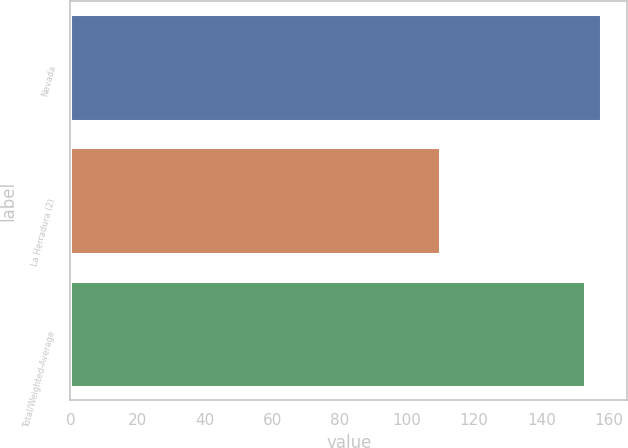<chart> <loc_0><loc_0><loc_500><loc_500><bar_chart><fcel>Nevada<fcel>La Herradura (2)<fcel>Total/Weighted-Average<nl><fcel>157.7<fcel>110<fcel>153<nl></chart> 